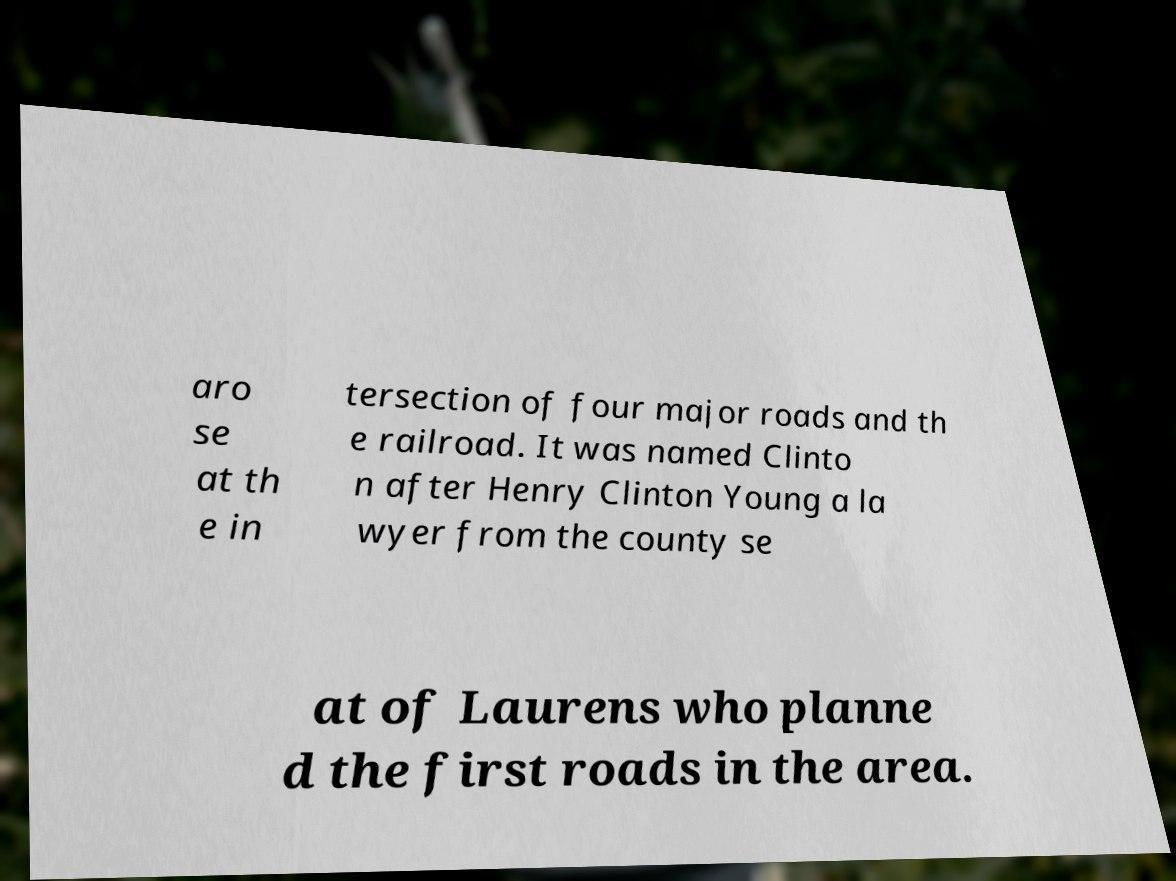Could you extract and type out the text from this image? aro se at th e in tersection of four major roads and th e railroad. It was named Clinto n after Henry Clinton Young a la wyer from the county se at of Laurens who planne d the first roads in the area. 